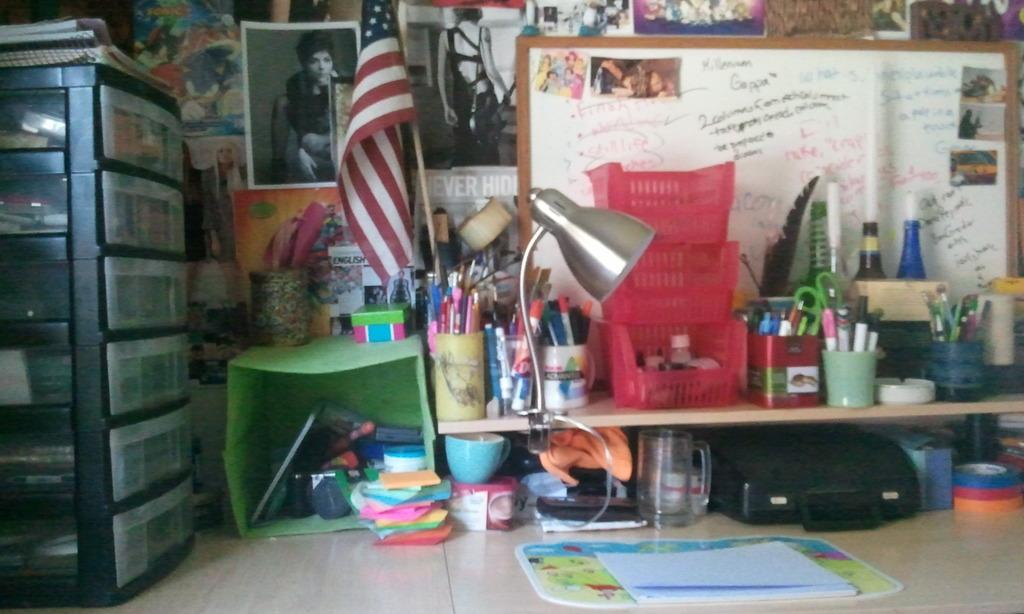Provide a one-sentence caption for the provided image. a desk with a white board with words and numbers like 2 on it. 